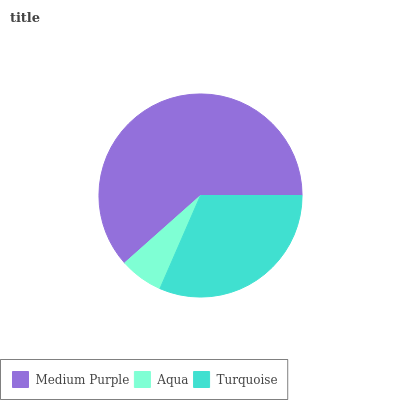Is Aqua the minimum?
Answer yes or no. Yes. Is Medium Purple the maximum?
Answer yes or no. Yes. Is Turquoise the minimum?
Answer yes or no. No. Is Turquoise the maximum?
Answer yes or no. No. Is Turquoise greater than Aqua?
Answer yes or no. Yes. Is Aqua less than Turquoise?
Answer yes or no. Yes. Is Aqua greater than Turquoise?
Answer yes or no. No. Is Turquoise less than Aqua?
Answer yes or no. No. Is Turquoise the high median?
Answer yes or no. Yes. Is Turquoise the low median?
Answer yes or no. Yes. Is Medium Purple the high median?
Answer yes or no. No. Is Aqua the low median?
Answer yes or no. No. 